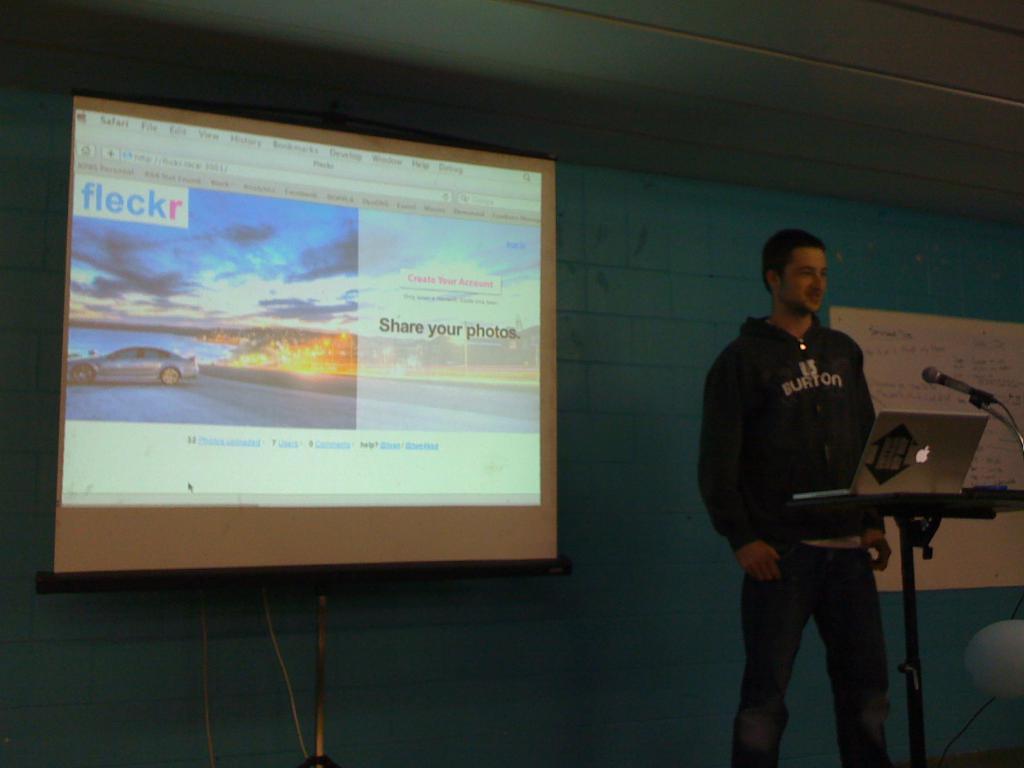What should you do with your photos?
Make the answer very short. Share. Which website is displayed on the screen?
Offer a terse response. Fleckr. 